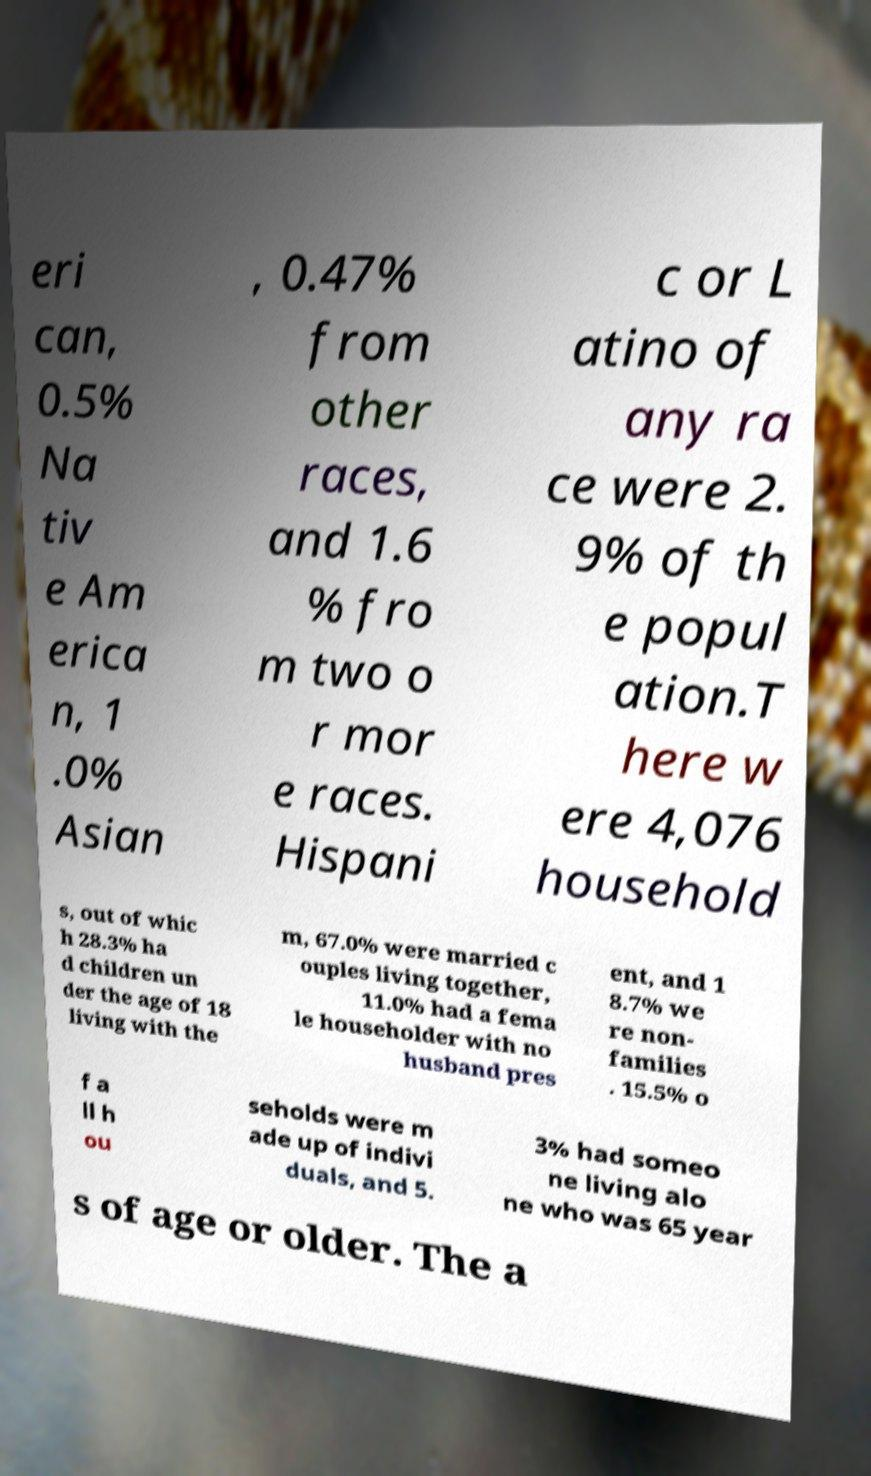What messages or text are displayed in this image? I need them in a readable, typed format. eri can, 0.5% Na tiv e Am erica n, 1 .0% Asian , 0.47% from other races, and 1.6 % fro m two o r mor e races. Hispani c or L atino of any ra ce were 2. 9% of th e popul ation.T here w ere 4,076 household s, out of whic h 28.3% ha d children un der the age of 18 living with the m, 67.0% were married c ouples living together, 11.0% had a fema le householder with no husband pres ent, and 1 8.7% we re non- families . 15.5% o f a ll h ou seholds were m ade up of indivi duals, and 5. 3% had someo ne living alo ne who was 65 year s of age or older. The a 